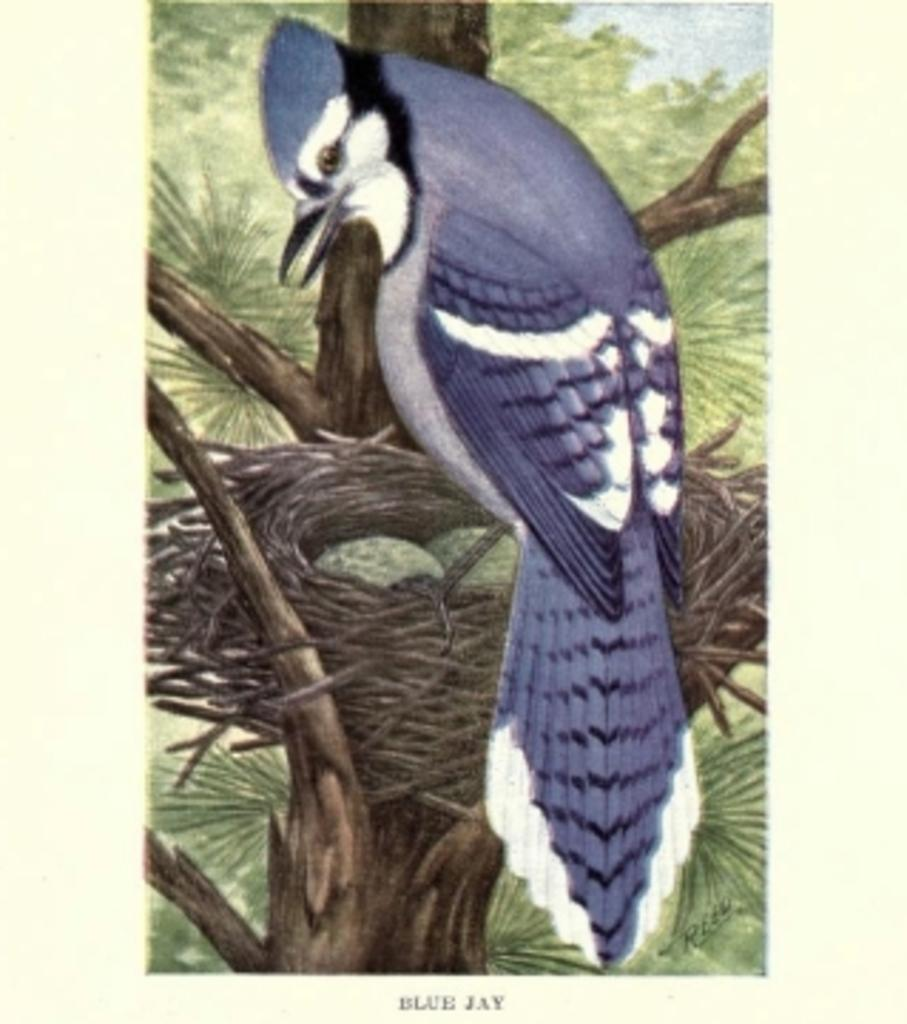What is featured on the poster in the image? The poster depicts a bird on a nest. What type of vegetation can be seen in the image? Trees are present in the image. What type of sail can be seen on the bird in the image? There is no sail present on the bird in the image; it is a bird on a nest, not a sailboat. Is there a collar visible on the bird in the image? There is no collar present on the bird in the image; it is a bird on a nest, and birds do not typically wear collars. 